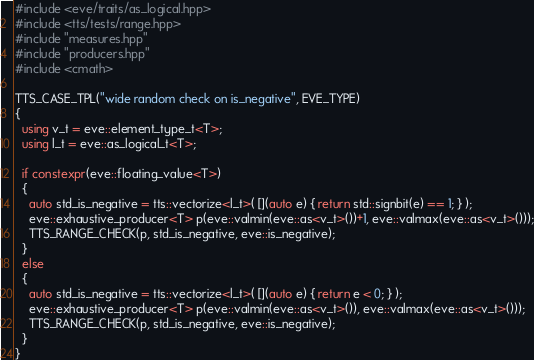<code> <loc_0><loc_0><loc_500><loc_500><_C++_>#include <eve/traits/as_logical.hpp>
#include <tts/tests/range.hpp>
#include "measures.hpp"
#include "producers.hpp"
#include <cmath>

TTS_CASE_TPL("wide random check on is_negative", EVE_TYPE)
{
  using v_t = eve::element_type_t<T>;
  using l_t = eve::as_logical_t<T>;

  if constexpr(eve::floating_value<T>)
  {
    auto std_is_negative = tts::vectorize<l_t>( [](auto e) { return std::signbit(e) == 1; } );
    eve::exhaustive_producer<T> p(eve::valmin(eve::as<v_t>())+1, eve::valmax(eve::as<v_t>()));
    TTS_RANGE_CHECK(p, std_is_negative, eve::is_negative);
  }
  else
  {
    auto std_is_negative = tts::vectorize<l_t>( [](auto e) { return e < 0; } );
    eve::exhaustive_producer<T> p(eve::valmin(eve::as<v_t>()), eve::valmax(eve::as<v_t>()));
    TTS_RANGE_CHECK(p, std_is_negative, eve::is_negative);
  }
}
</code> 